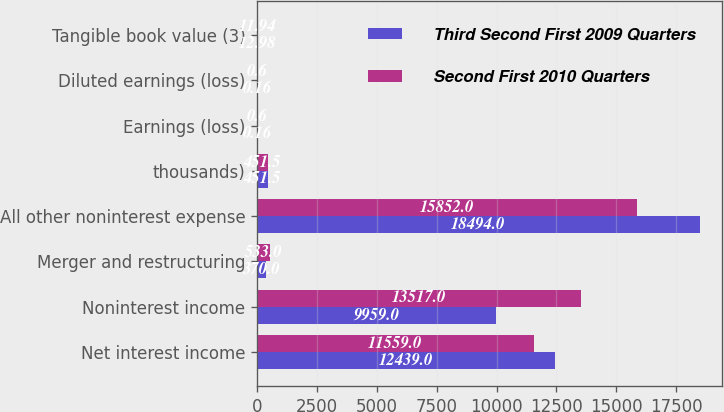Convert chart to OTSL. <chart><loc_0><loc_0><loc_500><loc_500><stacked_bar_chart><ecel><fcel>Net interest income<fcel>Noninterest income<fcel>Merger and restructuring<fcel>All other noninterest expense<fcel>thousands)<fcel>Earnings (loss)<fcel>Diluted earnings (loss)<fcel>Tangible book value (3)<nl><fcel>Third Second First 2009 Quarters<fcel>12439<fcel>9959<fcel>370<fcel>18494<fcel>451.5<fcel>0.16<fcel>0.16<fcel>12.98<nl><fcel>Second First 2010 Quarters<fcel>11559<fcel>13517<fcel>533<fcel>15852<fcel>451.5<fcel>0.6<fcel>0.6<fcel>11.94<nl></chart> 